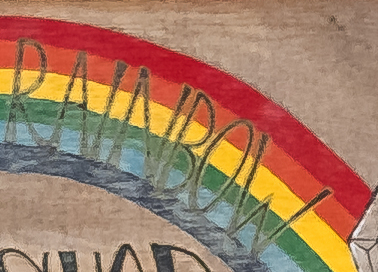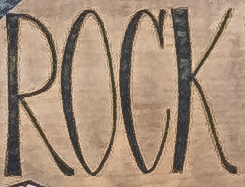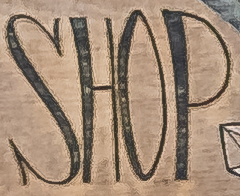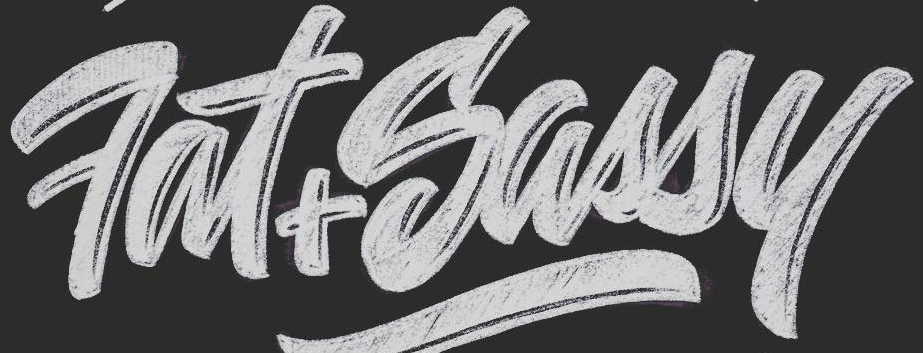What text appears in these images from left to right, separated by a semicolon? RNNBOW; ROCK; SHOP; Fat+Sassy 